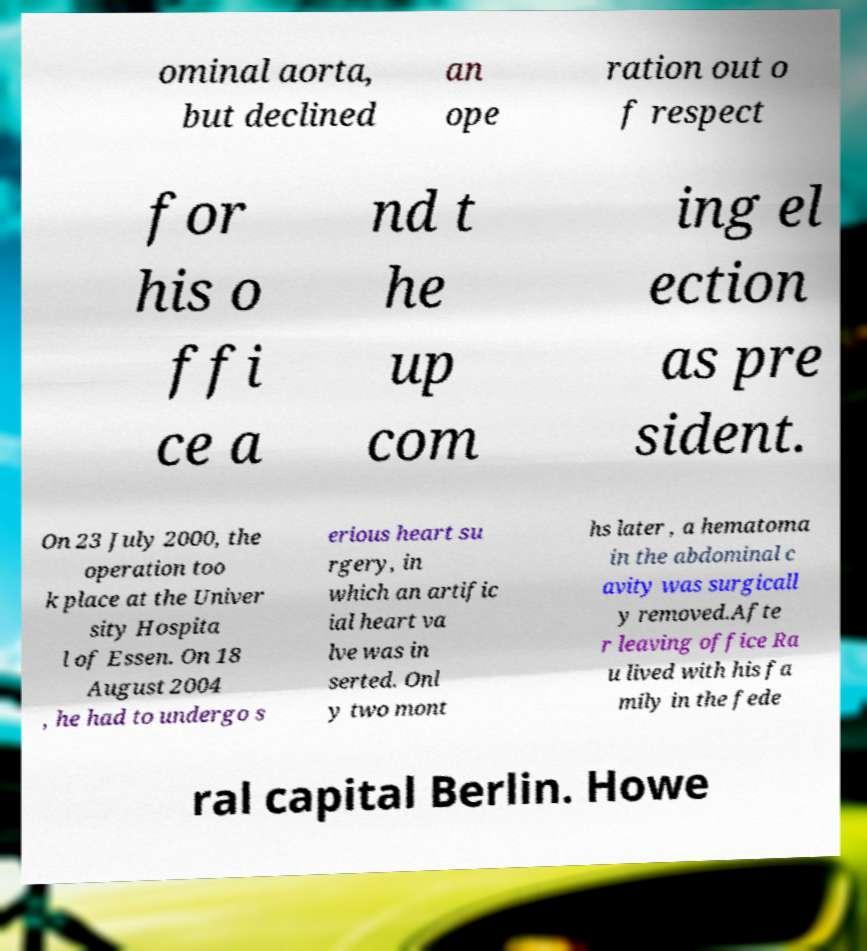Please identify and transcribe the text found in this image. ominal aorta, but declined an ope ration out o f respect for his o ffi ce a nd t he up com ing el ection as pre sident. On 23 July 2000, the operation too k place at the Univer sity Hospita l of Essen. On 18 August 2004 , he had to undergo s erious heart su rgery, in which an artific ial heart va lve was in serted. Onl y two mont hs later , a hematoma in the abdominal c avity was surgicall y removed.Afte r leaving office Ra u lived with his fa mily in the fede ral capital Berlin. Howe 